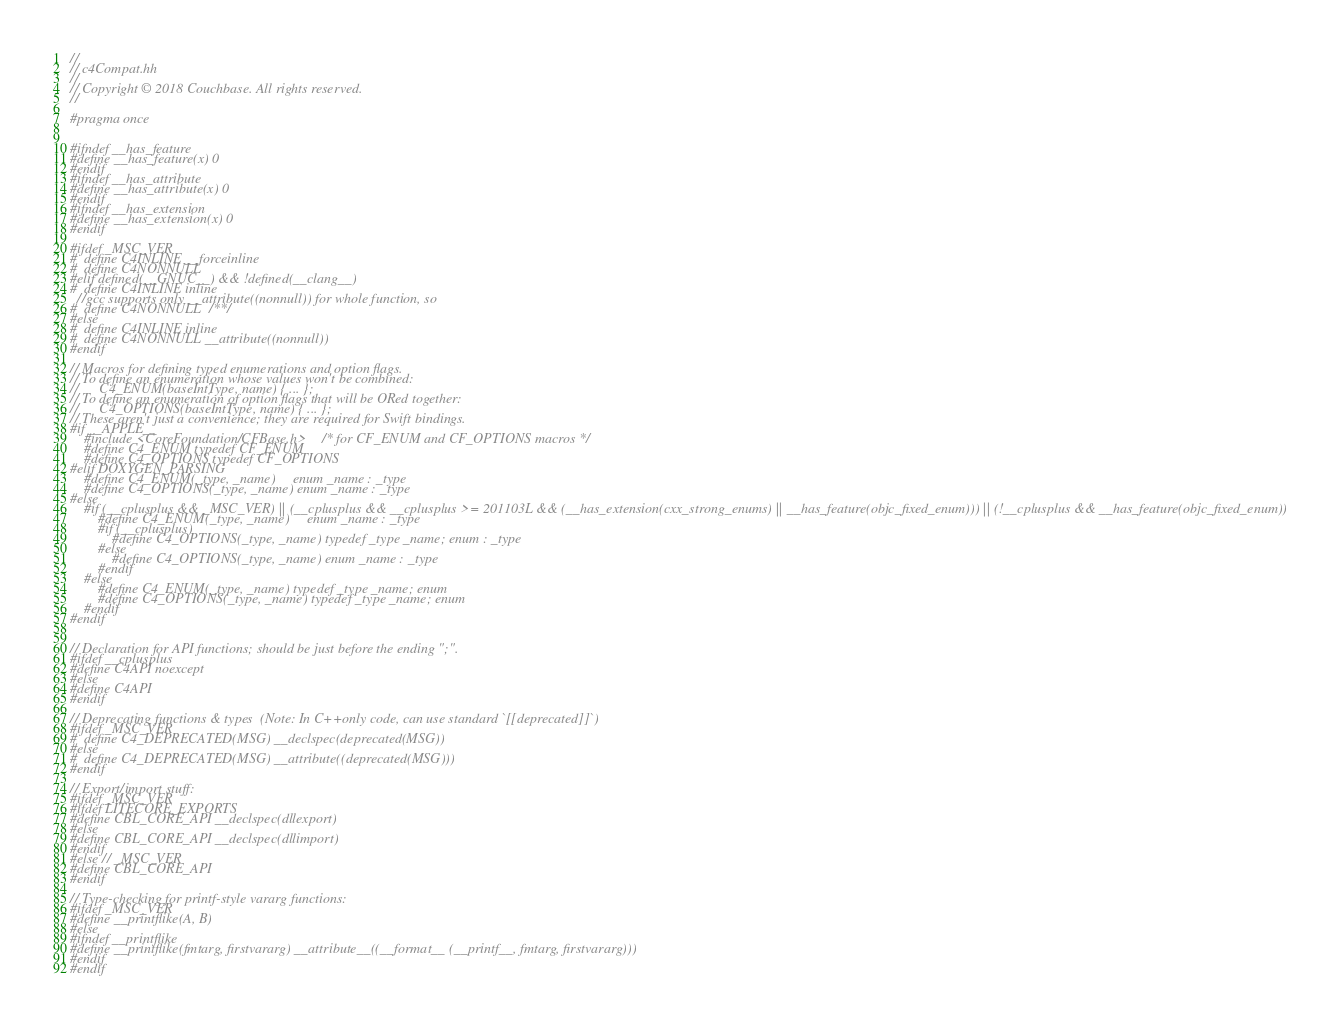Convert code to text. <code><loc_0><loc_0><loc_500><loc_500><_C_>//
// c4Compat.hh
//
// Copyright © 2018 Couchbase. All rights reserved.
//

#pragma once


#ifndef __has_feature
#define __has_feature(x) 0
#endif
#ifndef __has_attribute
#define __has_attribute(x) 0
#endif
#ifndef __has_extension
#define __has_extension(x) 0
#endif

#ifdef _MSC_VER
#  define C4INLINE __forceinline
#  define C4NONNULL
#elif defined(__GNUC__) && !defined(__clang__)
#  define C4INLINE inline
  //gcc supports only __attribute((nonnull)) for whole function, so
#  define C4NONNULL /**/
#else
#  define C4INLINE inline
#  define C4NONNULL __attribute((nonnull))
#endif

// Macros for defining typed enumerations and option flags.
// To define an enumeration whose values won't be combined:
//      C4_ENUM(baseIntType, name) { ... };
// To define an enumeration of option flags that will be ORed together:
//      C4_OPTIONS(baseIntType, name) { ... };
// These aren't just a convenience; they are required for Swift bindings.
#if __APPLE__
    #include <CoreFoundation/CFBase.h>      /* for CF_ENUM and CF_OPTIONS macros */
    #define C4_ENUM typedef CF_ENUM
    #define C4_OPTIONS typedef CF_OPTIONS
#elif DOXYGEN_PARSING
    #define C4_ENUM(_type, _name)     enum _name : _type
    #define C4_OPTIONS(_type, _name) enum _name : _type
#else
    #if (__cplusplus && _MSC_VER) || (__cplusplus && __cplusplus >= 201103L && (__has_extension(cxx_strong_enums) || __has_feature(objc_fixed_enum))) || (!__cplusplus && __has_feature(objc_fixed_enum))
        #define C4_ENUM(_type, _name)     enum _name : _type
        #if (__cplusplus)
            #define C4_OPTIONS(_type, _name) typedef _type _name; enum : _type
        #else
            #define C4_OPTIONS(_type, _name) enum _name : _type
        #endif
    #else
        #define C4_ENUM(_type, _name) typedef _type _name; enum
        #define C4_OPTIONS(_type, _name) typedef _type _name; enum
    #endif
#endif


// Declaration for API functions; should be just before the ending ";".
#ifdef __cplusplus
#define C4API noexcept
#else
#define C4API
#endif

// Deprecating functions & types  (Note: In C++only code, can use standard `[[deprecated]]`)
#ifdef _MSC_VER
#  define C4_DEPRECATED(MSG) __declspec(deprecated(MSG))
#else
#  define C4_DEPRECATED(MSG) __attribute((deprecated(MSG)))
#endif

// Export/import stuff:
#ifdef _MSC_VER
#ifdef LITECORE_EXPORTS
#define CBL_CORE_API __declspec(dllexport)
#else
#define CBL_CORE_API __declspec(dllimport)
#endif
#else // _MSC_VER
#define CBL_CORE_API
#endif

// Type-checking for printf-style vararg functions:
#ifdef _MSC_VER
#define __printflike(A, B)
#else
#ifndef __printflike
#define __printflike(fmtarg, firstvararg) __attribute__((__format__ (__printf__, fmtarg, firstvararg)))
#endif
#endif
</code> 